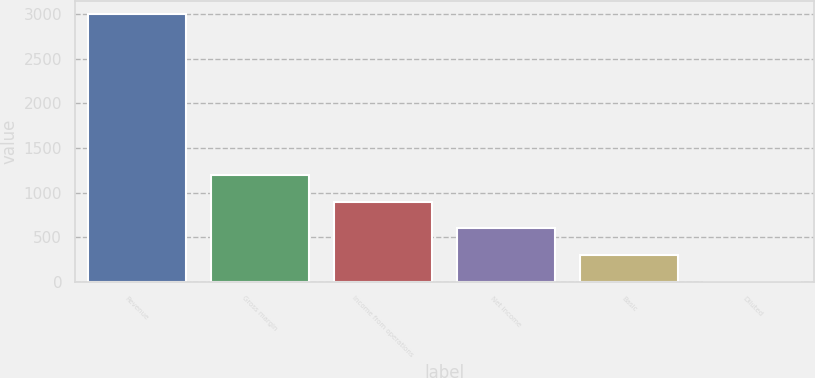<chart> <loc_0><loc_0><loc_500><loc_500><bar_chart><fcel>Revenue<fcel>Gross margin<fcel>Income from operations<fcel>Net income<fcel>Basic<fcel>Diluted<nl><fcel>2996<fcel>1198.55<fcel>898.97<fcel>599.39<fcel>299.81<fcel>0.23<nl></chart> 